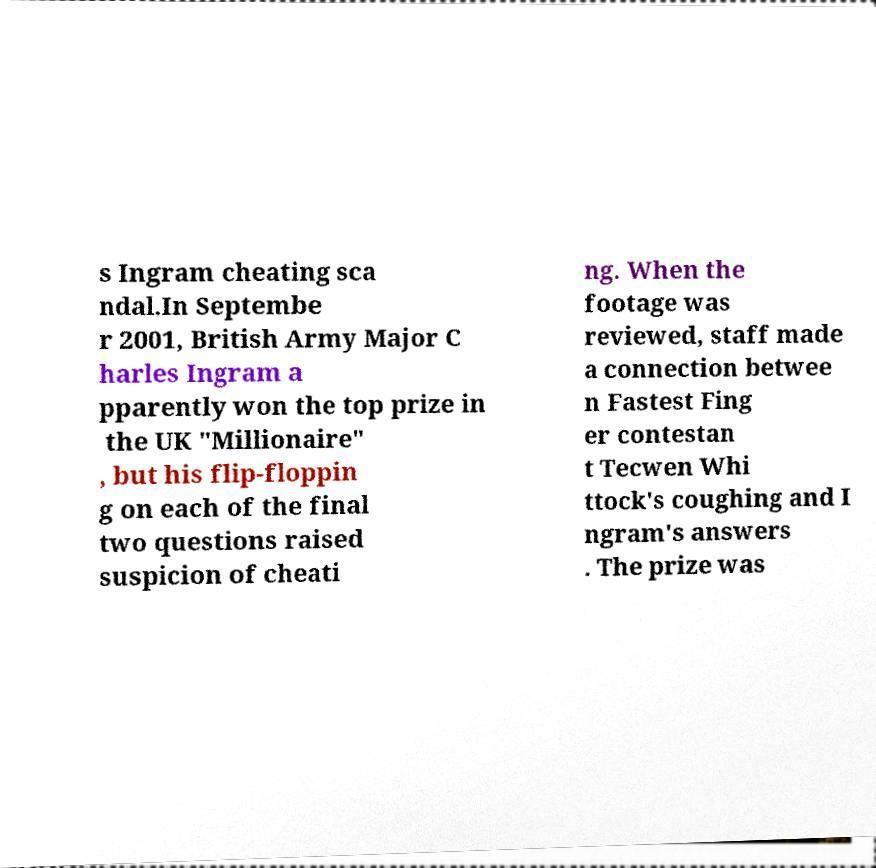What messages or text are displayed in this image? I need them in a readable, typed format. s Ingram cheating sca ndal.In Septembe r 2001, British Army Major C harles Ingram a pparently won the top prize in the UK "Millionaire" , but his flip-floppin g on each of the final two questions raised suspicion of cheati ng. When the footage was reviewed, staff made a connection betwee n Fastest Fing er contestan t Tecwen Whi ttock's coughing and I ngram's answers . The prize was 